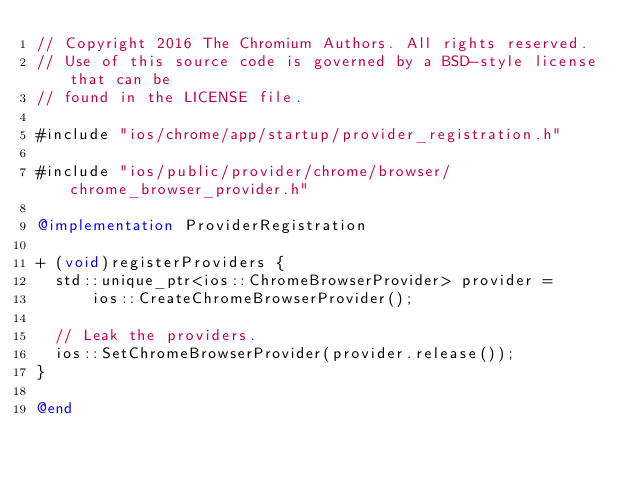Convert code to text. <code><loc_0><loc_0><loc_500><loc_500><_ObjectiveC_>// Copyright 2016 The Chromium Authors. All rights reserved.
// Use of this source code is governed by a BSD-style license that can be
// found in the LICENSE file.

#include "ios/chrome/app/startup/provider_registration.h"

#include "ios/public/provider/chrome/browser/chrome_browser_provider.h"

@implementation ProviderRegistration

+ (void)registerProviders {
  std::unique_ptr<ios::ChromeBrowserProvider> provider =
      ios::CreateChromeBrowserProvider();

  // Leak the providers.
  ios::SetChromeBrowserProvider(provider.release());
}

@end
</code> 